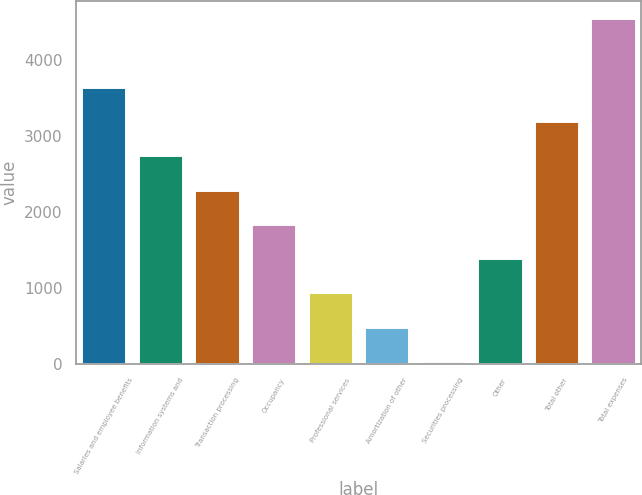Convert chart. <chart><loc_0><loc_0><loc_500><loc_500><bar_chart><fcel>Salaries and employee benefits<fcel>Information systems and<fcel>Transaction processing<fcel>Occupancy<fcel>Professional services<fcel>Amortization of other<fcel>Securities processing<fcel>Other<fcel>Total other<fcel>Total expenses<nl><fcel>3639.4<fcel>2738.8<fcel>2288.5<fcel>1838.2<fcel>937.6<fcel>487.3<fcel>37<fcel>1387.9<fcel>3189.1<fcel>4540<nl></chart> 